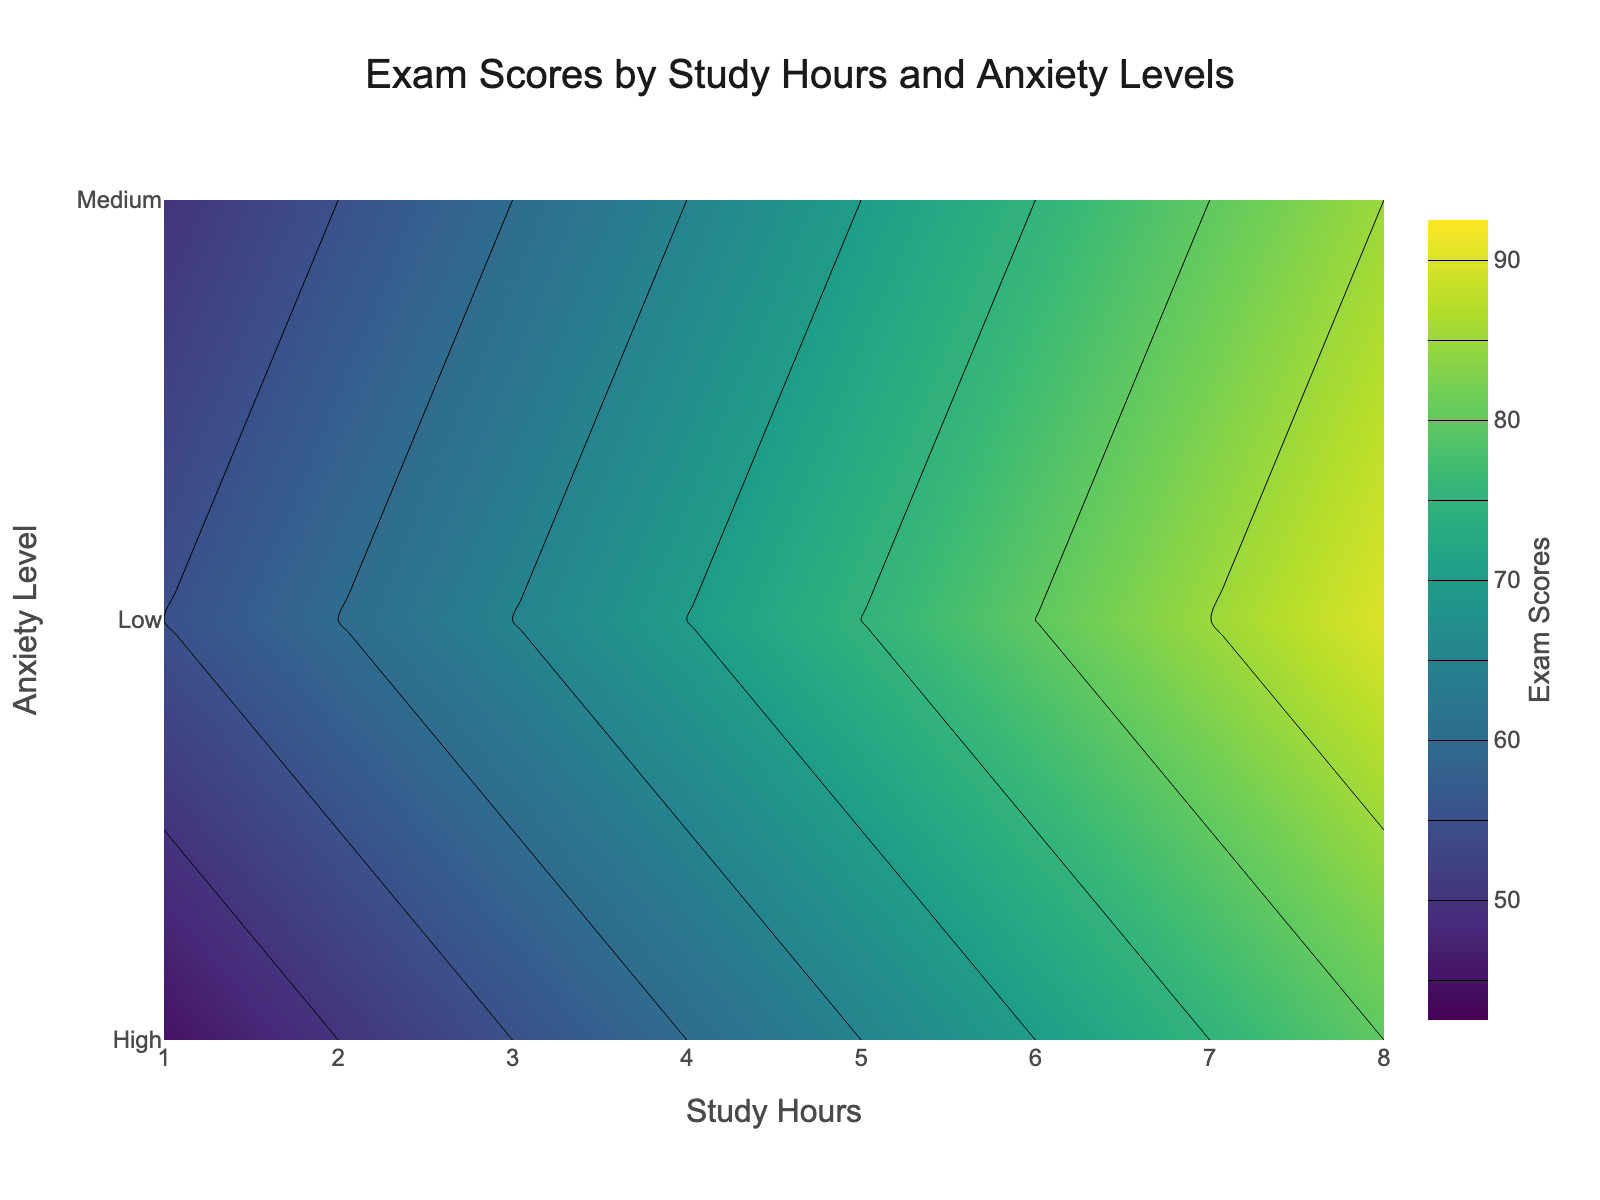What is the title of the figure? The title of the figure is usually located at the top and provides a brief description of what the plot represents.
Answer: Exam Scores by Study Hours and Anxiety Levels What axis represents the 'Study Hours'? The x-axis, typically the horizontal axis, represents the 'Study Hours' because it is labeled as such.
Answer: x-axis What is the contour color scheme used in the plot? The color scheme of a contour plot is often indicated in the colorbar alongside the plot. In this case, it uses the 'Viridis' color scale.
Answer: Viridis What is the range of 'Exam Scores' represented in the contour plot? The range of values shown in a contour plot is typically given in the colorbar. Here, the 'Exam Scores' range from 45 to 90.
Answer: 45 to 90 How do exam scores change with increasing study hours for students with high anxiety levels? To find this, observe the contour lines corresponding to 'High' anxiety level and note the trend in exam scores as study hours increase. The scores increase steadily from 45 to 80 as study hours increase from 1 to 8.
Answer: Scores increase At which study hours do medium anxiety levels yield an exam score of 70? Locate the contour line for the score of 70 and find where it intersects with the 'Medium' anxiety level. This intersection occurs at around 5 study hours.
Answer: 5 hours What is the difference in exam scores for low vs. high anxiety levels at 6 study hours? Identify the exam scores at 6 study hours for low and high anxiety levels, which are 80 and 70 respectively, then calculate the difference: 80 - 70 = 10.
Answer: 10 Which anxiety level corresponds to the lowest exam scores for 1 study hour? Examine the exam scores at 1 study hour across different anxiety levels. The lowest score is 45 for the high anxiety level.
Answer: High anxiety level How does the level of exam scores' improvement differ between students with low and medium anxiety as study hours increase from 2 to 4? Compare the increase in exam scores from 2 to 4 study hours for low anxiety (60 to 70) and medium anxiety (55 to 65), showing an increase of 10 for both.
Answer: Same improvement What is the average exam score for students with low anxiety level? To find the average, sum the exam scores for low anxiety (55, 60, 65, 70, 75, 80, 85, 90) and divide by the number of data points. (55 + 60 + 65 + 70 + 75 + 80 + 85 + 90) / 8 = 580 / 8 = 72.5.
Answer: 72.5 